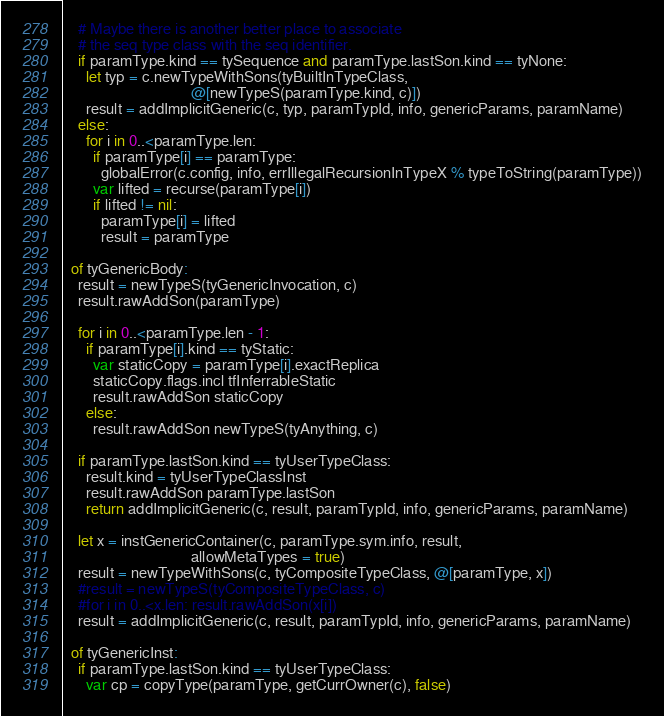<code> <loc_0><loc_0><loc_500><loc_500><_Nim_>    # Maybe there is another better place to associate
    # the seq type class with the seq identifier.
    if paramType.kind == tySequence and paramType.lastSon.kind == tyNone:
      let typ = c.newTypeWithSons(tyBuiltInTypeClass,
                                  @[newTypeS(paramType.kind, c)])
      result = addImplicitGeneric(c, typ, paramTypId, info, genericParams, paramName)
    else:
      for i in 0..<paramType.len:
        if paramType[i] == paramType:
          globalError(c.config, info, errIllegalRecursionInTypeX % typeToString(paramType))
        var lifted = recurse(paramType[i])
        if lifted != nil:
          paramType[i] = lifted
          result = paramType

  of tyGenericBody:
    result = newTypeS(tyGenericInvocation, c)
    result.rawAddSon(paramType)

    for i in 0..<paramType.len - 1:
      if paramType[i].kind == tyStatic:
        var staticCopy = paramType[i].exactReplica
        staticCopy.flags.incl tfInferrableStatic
        result.rawAddSon staticCopy
      else:
        result.rawAddSon newTypeS(tyAnything, c)

    if paramType.lastSon.kind == tyUserTypeClass:
      result.kind = tyUserTypeClassInst
      result.rawAddSon paramType.lastSon
      return addImplicitGeneric(c, result, paramTypId, info, genericParams, paramName)

    let x = instGenericContainer(c, paramType.sym.info, result,
                                  allowMetaTypes = true)
    result = newTypeWithSons(c, tyCompositeTypeClass, @[paramType, x])
    #result = newTypeS(tyCompositeTypeClass, c)
    #for i in 0..<x.len: result.rawAddSon(x[i])
    result = addImplicitGeneric(c, result, paramTypId, info, genericParams, paramName)

  of tyGenericInst:
    if paramType.lastSon.kind == tyUserTypeClass:
      var cp = copyType(paramType, getCurrOwner(c), false)</code> 